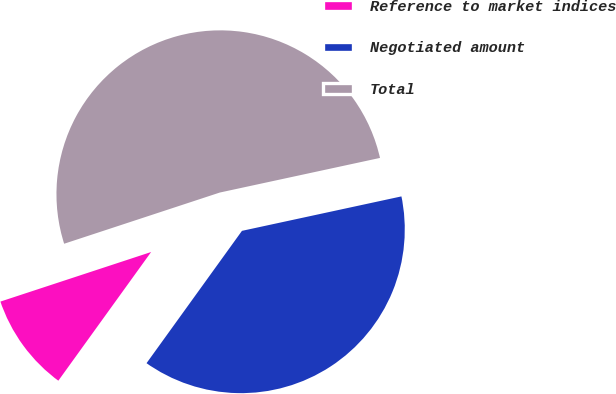<chart> <loc_0><loc_0><loc_500><loc_500><pie_chart><fcel>Reference to market indices<fcel>Negotiated amount<fcel>Total<nl><fcel>10.0%<fcel>38.33%<fcel>51.67%<nl></chart> 